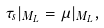<formula> <loc_0><loc_0><loc_500><loc_500>\tau _ { s } | _ { M _ { L } } = \mu | _ { M _ { L } } ,</formula> 